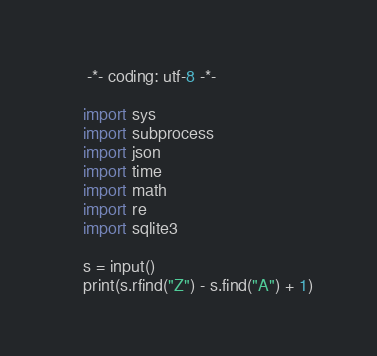<code> <loc_0><loc_0><loc_500><loc_500><_Python_>

     -*- coding: utf-8 -*-
     
    import sys
    import subprocess
    import json
    import time
    import math
    import re
    import sqlite3
     
    s = input()
    print(s.rfind("Z") - s.find("A") + 1)</code> 